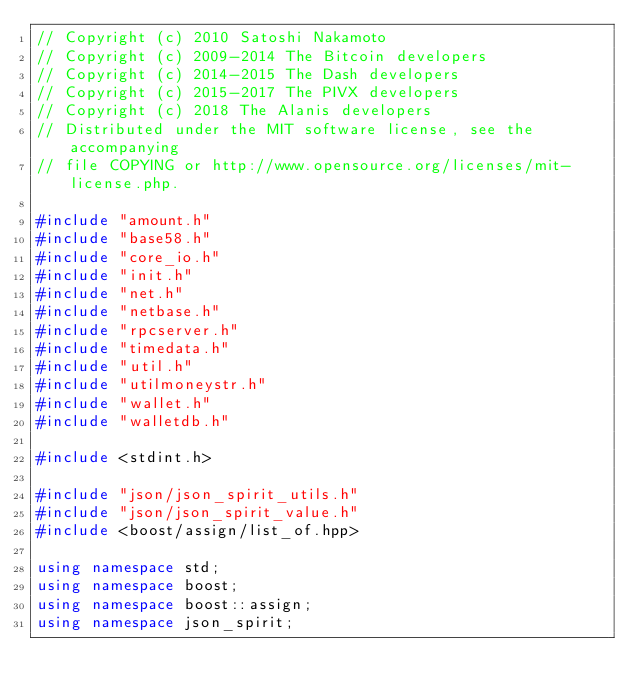Convert code to text. <code><loc_0><loc_0><loc_500><loc_500><_C++_>// Copyright (c) 2010 Satoshi Nakamoto
// Copyright (c) 2009-2014 The Bitcoin developers
// Copyright (c) 2014-2015 The Dash developers
// Copyright (c) 2015-2017 The PIVX developers 
// Copyright (c) 2018 The Alanis developers
// Distributed under the MIT software license, see the accompanying
// file COPYING or http://www.opensource.org/licenses/mit-license.php.

#include "amount.h"
#include "base58.h"
#include "core_io.h"
#include "init.h"
#include "net.h"
#include "netbase.h"
#include "rpcserver.h"
#include "timedata.h"
#include "util.h"
#include "utilmoneystr.h"
#include "wallet.h"
#include "walletdb.h"

#include <stdint.h>

#include "json/json_spirit_utils.h"
#include "json/json_spirit_value.h"
#include <boost/assign/list_of.hpp>

using namespace std;
using namespace boost;
using namespace boost::assign;
using namespace json_spirit;
</code> 